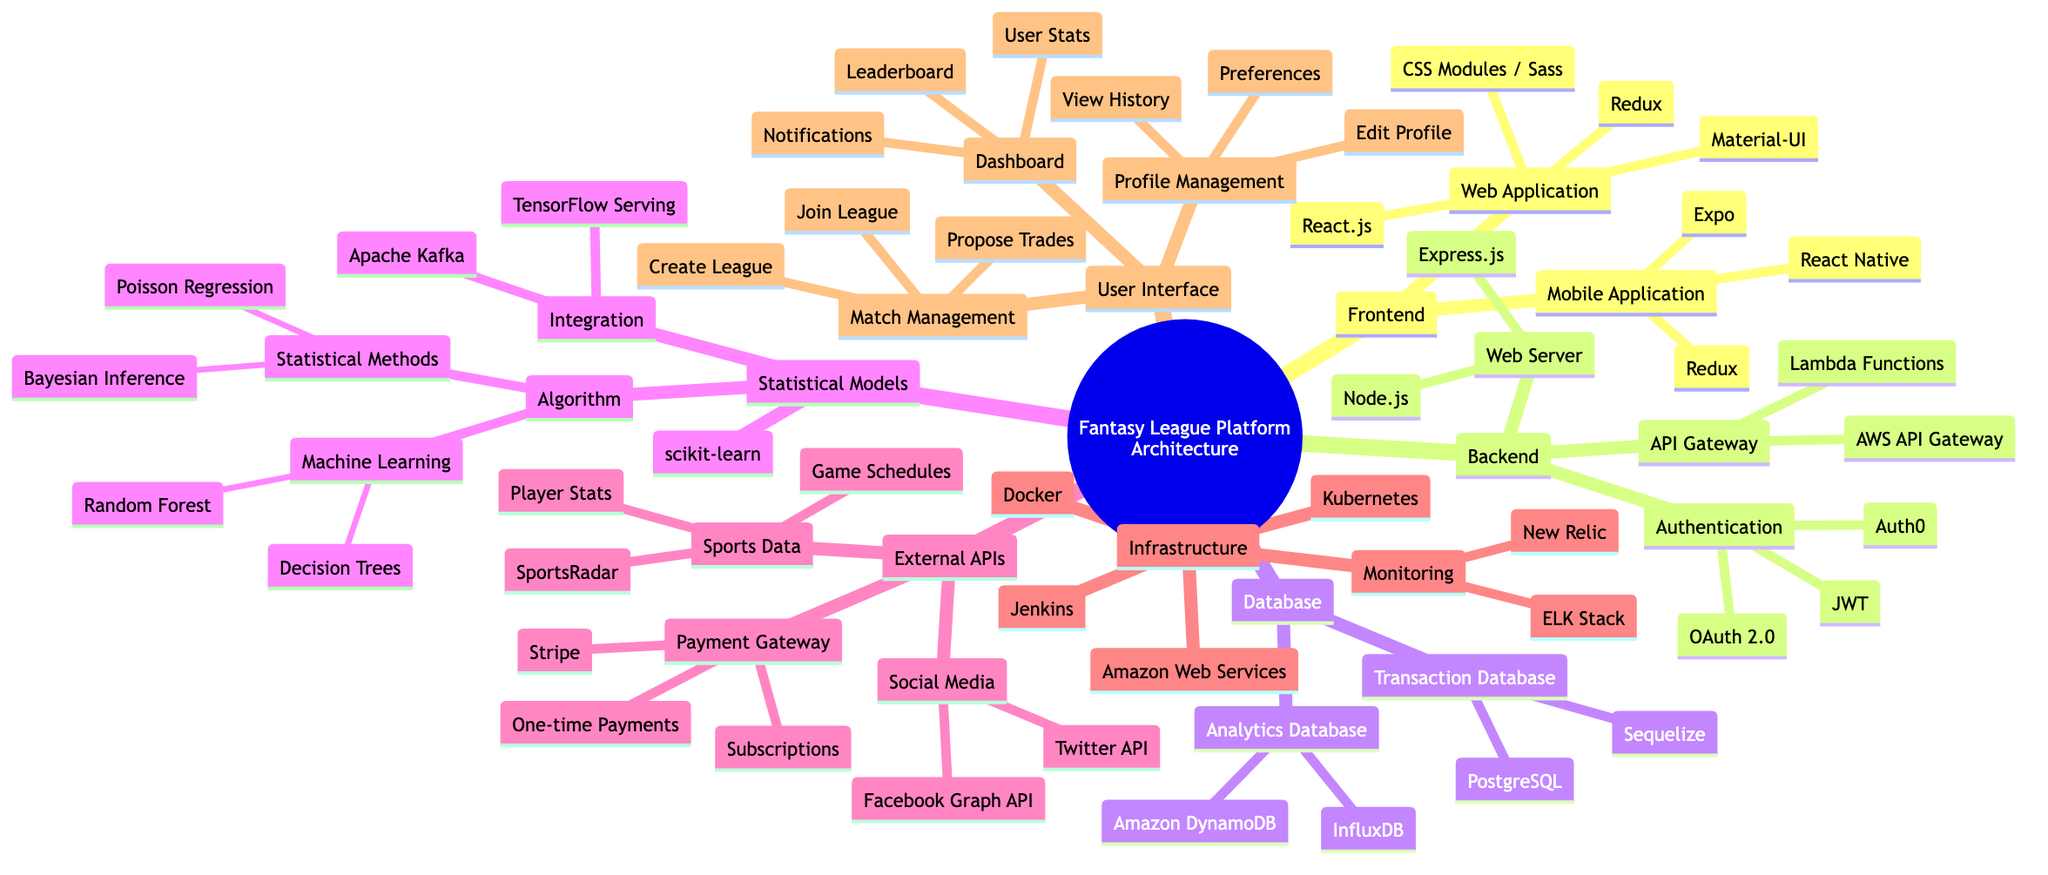What framework is used for the Web Application? The diagram indicates that the Web Application under the Frontend section uses React.js as its framework. It is shown clearly as the first node in the Web Application branch.
Answer: React.js How many machine learning algorithms are listed in the Statistical Models section? In the Statistical Models section, there are two machine learning algorithms mentioned: Decision Trees and Random Forest. Counting these two listed algorithms gives a total of two.
Answer: 2 Which cloud provider is utilized for the Infrastructure? The Infrastructure section clearly states that Amazon Web Services is the cloud provider being used for this platform. This is visible in the first node of the Infrastructure branch.
Answer: Amazon Web Services What kind of database is used for transactions? The diagram specifies that the Transaction Database uses a Relational Database type; it is indicated in the Database section as the type used within the Transaction Database node.
Answer: Relational Database Which service is responsible for payment gateway functionalities? The External APIs section lists Stripe as the service responsible for the Payment Gateway functionalities. This information is indicated under the Payment Gateway node.
Answer: Stripe What is the primary purpose of Apache Kafka in the Statistical Models section? Apache Kafka is mentioned under the Integration node within the Statistical Models section, indicating its role as a Data Pipeline. This implies its primary purpose is to handle data asynchronously for statistical model processes.
Answer: Data Pipeline What is the main purpose of the Dashboard in the User Interface? The Dashboard in the User Interface section includes features such as User Stats, Leaderboard, and Notifications; thus, its main purpose is to provide users with an overview and statistical insights about their league performance.
Answer: Overview of user stats and performance How many services are listed under the External APIs section? In the External APIs section, there are three distinct services mentioned: Sports Data, Payment Gateway, and Social Media. This provides a straightforward way to count and find that there are three services.
Answer: 3 What technology is used for containerization in the Infrastructure? The Infrastructure section specifies that Docker is the technology utilized for containerization, clearly indicated in a dedicated node.
Answer: Docker 